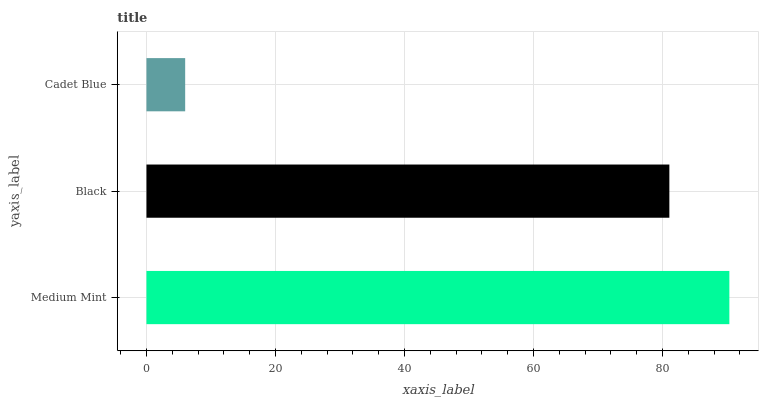Is Cadet Blue the minimum?
Answer yes or no. Yes. Is Medium Mint the maximum?
Answer yes or no. Yes. Is Black the minimum?
Answer yes or no. No. Is Black the maximum?
Answer yes or no. No. Is Medium Mint greater than Black?
Answer yes or no. Yes. Is Black less than Medium Mint?
Answer yes or no. Yes. Is Black greater than Medium Mint?
Answer yes or no. No. Is Medium Mint less than Black?
Answer yes or no. No. Is Black the high median?
Answer yes or no. Yes. Is Black the low median?
Answer yes or no. Yes. Is Cadet Blue the high median?
Answer yes or no. No. Is Cadet Blue the low median?
Answer yes or no. No. 